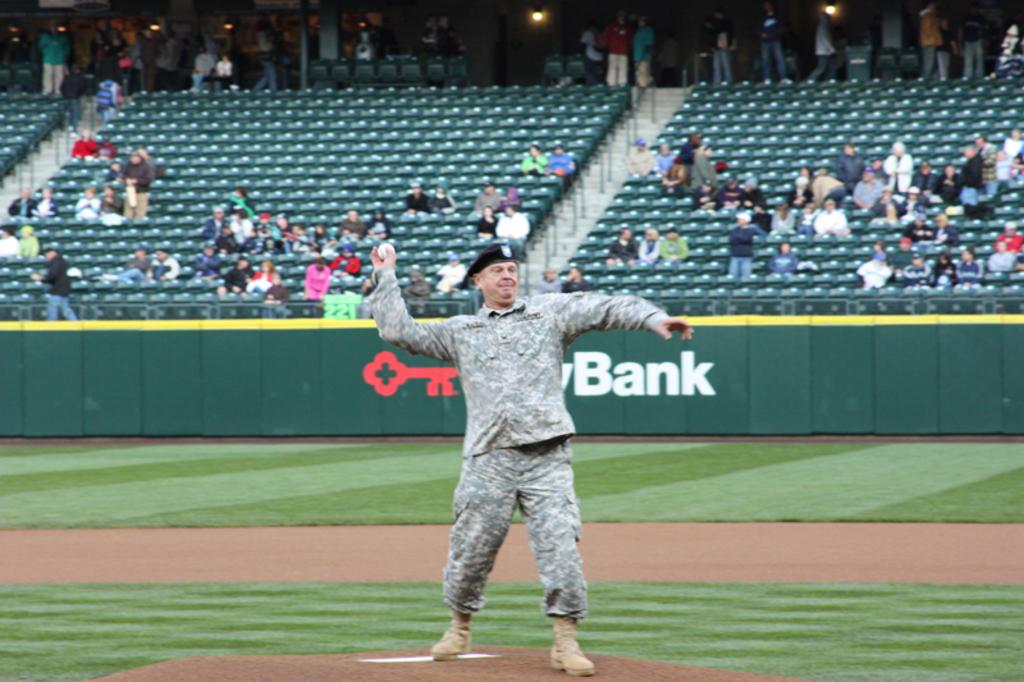What word is on the fence behind the soldier?
Offer a very short reply. Bank. 